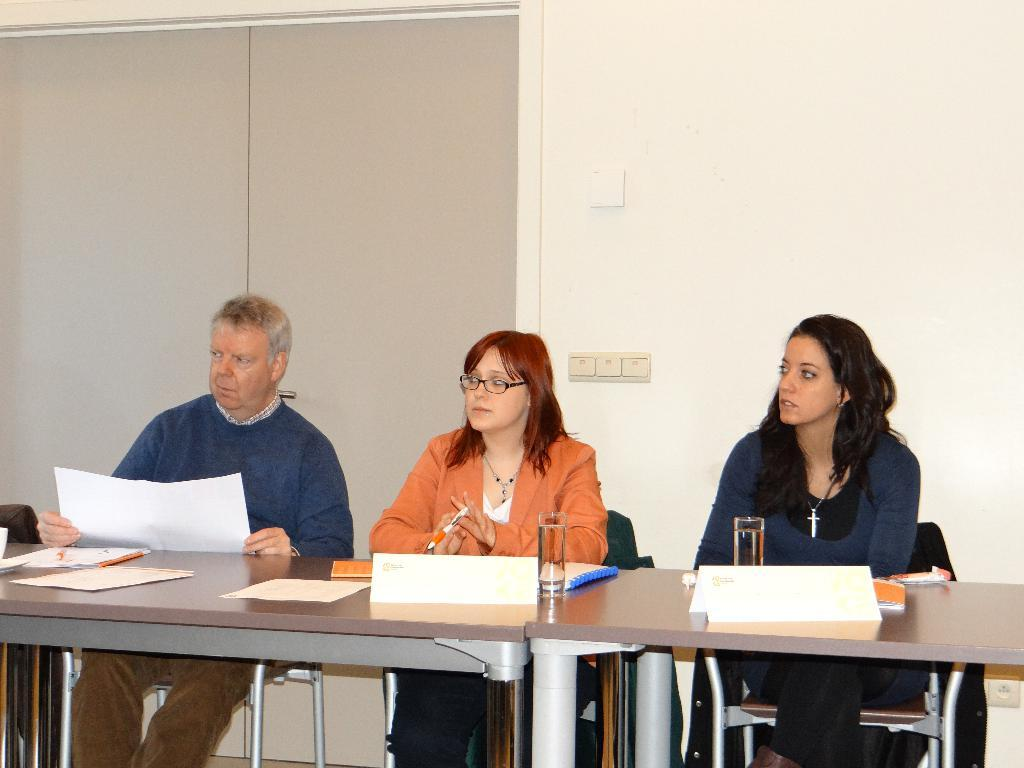What are the persons in the image doing? The persons in the image are sitting on chairs. What is one person holding? One person is holding a paper. What is another person holding? Another person is holding a pen. What can be seen in the background of the image? There is a wall, a door, and a switch board in the background. What type of shirt is the yam wearing in the image? There is no yam present in the image, and therefore no shirt can be associated with it. 